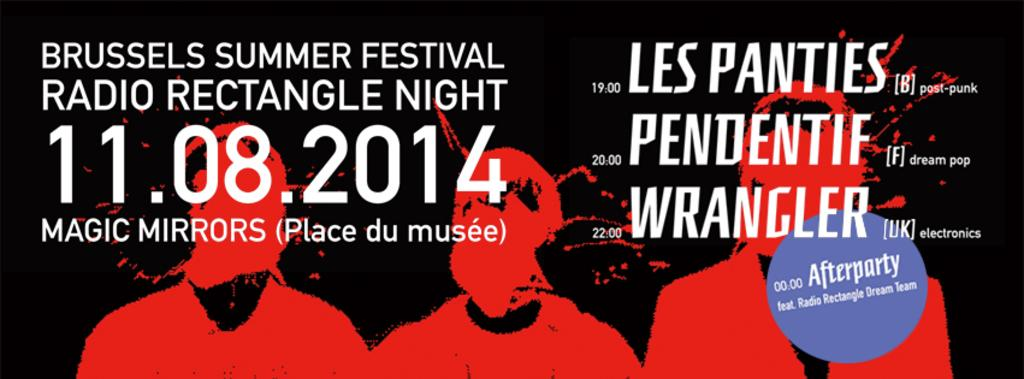What is present in the image that contains information or a message? There is a poster in the image. Can you describe what is written on the poster? There is text written on the poster. What type of shirt is hanging on the tree in the image? There is no shirt or tree present in the image; it only contains a poster with text. 